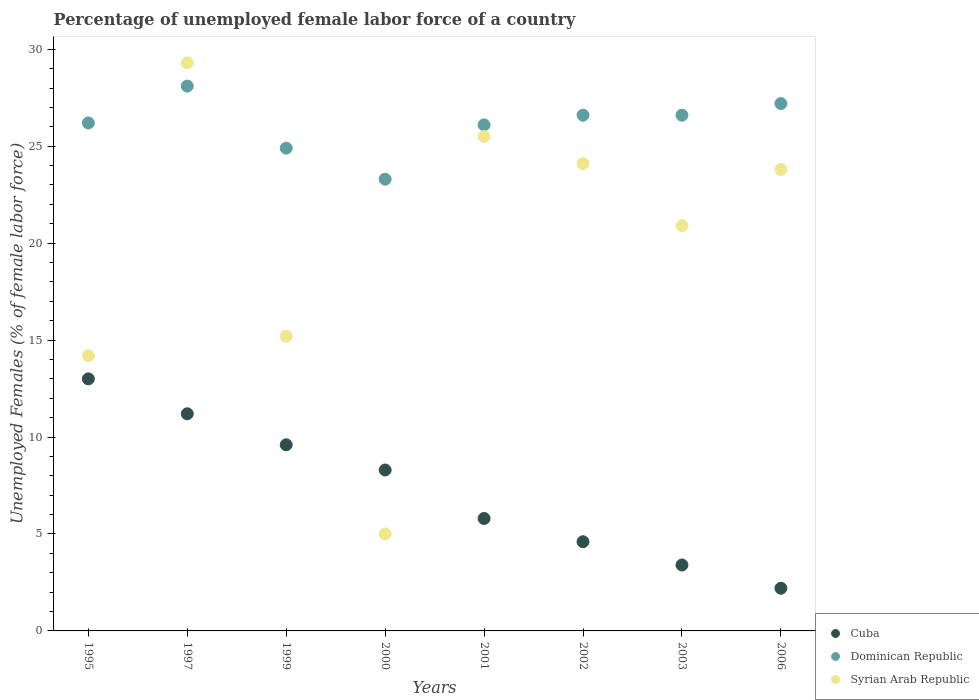Is the number of dotlines equal to the number of legend labels?
Make the answer very short. Yes. Across all years, what is the maximum percentage of unemployed female labor force in Dominican Republic?
Provide a short and direct response. 28.1. Across all years, what is the minimum percentage of unemployed female labor force in Dominican Republic?
Offer a terse response. 23.3. What is the total percentage of unemployed female labor force in Cuba in the graph?
Provide a short and direct response. 58.1. What is the difference between the percentage of unemployed female labor force in Syrian Arab Republic in 2002 and that in 2006?
Offer a very short reply. 0.3. What is the difference between the percentage of unemployed female labor force in Syrian Arab Republic in 2003 and the percentage of unemployed female labor force in Cuba in 2000?
Your response must be concise. 12.6. What is the average percentage of unemployed female labor force in Cuba per year?
Give a very brief answer. 7.26. In the year 2002, what is the difference between the percentage of unemployed female labor force in Cuba and percentage of unemployed female labor force in Dominican Republic?
Give a very brief answer. -22. What is the ratio of the percentage of unemployed female labor force in Syrian Arab Republic in 2000 to that in 2006?
Your response must be concise. 0.21. What is the difference between the highest and the second highest percentage of unemployed female labor force in Cuba?
Ensure brevity in your answer.  1.8. What is the difference between the highest and the lowest percentage of unemployed female labor force in Dominican Republic?
Ensure brevity in your answer.  4.8. Is the sum of the percentage of unemployed female labor force in Dominican Republic in 1997 and 2002 greater than the maximum percentage of unemployed female labor force in Syrian Arab Republic across all years?
Give a very brief answer. Yes. Is it the case that in every year, the sum of the percentage of unemployed female labor force in Dominican Republic and percentage of unemployed female labor force in Cuba  is greater than the percentage of unemployed female labor force in Syrian Arab Republic?
Your answer should be very brief. Yes. Does the percentage of unemployed female labor force in Cuba monotonically increase over the years?
Offer a very short reply. No. Is the percentage of unemployed female labor force in Syrian Arab Republic strictly greater than the percentage of unemployed female labor force in Cuba over the years?
Offer a very short reply. No. How many years are there in the graph?
Provide a short and direct response. 8. Are the values on the major ticks of Y-axis written in scientific E-notation?
Give a very brief answer. No. Does the graph contain any zero values?
Ensure brevity in your answer.  No. How many legend labels are there?
Offer a very short reply. 3. How are the legend labels stacked?
Your answer should be compact. Vertical. What is the title of the graph?
Provide a short and direct response. Percentage of unemployed female labor force of a country. Does "Georgia" appear as one of the legend labels in the graph?
Your answer should be compact. No. What is the label or title of the Y-axis?
Provide a short and direct response. Unemployed Females (% of female labor force). What is the Unemployed Females (% of female labor force) in Cuba in 1995?
Your answer should be very brief. 13. What is the Unemployed Females (% of female labor force) of Dominican Republic in 1995?
Give a very brief answer. 26.2. What is the Unemployed Females (% of female labor force) in Syrian Arab Republic in 1995?
Give a very brief answer. 14.2. What is the Unemployed Females (% of female labor force) in Cuba in 1997?
Your answer should be very brief. 11.2. What is the Unemployed Females (% of female labor force) in Dominican Republic in 1997?
Your response must be concise. 28.1. What is the Unemployed Females (% of female labor force) of Syrian Arab Republic in 1997?
Ensure brevity in your answer.  29.3. What is the Unemployed Females (% of female labor force) in Cuba in 1999?
Offer a very short reply. 9.6. What is the Unemployed Females (% of female labor force) in Dominican Republic in 1999?
Make the answer very short. 24.9. What is the Unemployed Females (% of female labor force) of Syrian Arab Republic in 1999?
Offer a very short reply. 15.2. What is the Unemployed Females (% of female labor force) of Cuba in 2000?
Provide a short and direct response. 8.3. What is the Unemployed Females (% of female labor force) in Dominican Republic in 2000?
Provide a succinct answer. 23.3. What is the Unemployed Females (% of female labor force) of Cuba in 2001?
Provide a short and direct response. 5.8. What is the Unemployed Females (% of female labor force) in Dominican Republic in 2001?
Keep it short and to the point. 26.1. What is the Unemployed Females (% of female labor force) in Syrian Arab Republic in 2001?
Give a very brief answer. 25.5. What is the Unemployed Females (% of female labor force) in Cuba in 2002?
Your answer should be very brief. 4.6. What is the Unemployed Females (% of female labor force) of Dominican Republic in 2002?
Your response must be concise. 26.6. What is the Unemployed Females (% of female labor force) in Syrian Arab Republic in 2002?
Offer a terse response. 24.1. What is the Unemployed Females (% of female labor force) of Cuba in 2003?
Make the answer very short. 3.4. What is the Unemployed Females (% of female labor force) in Dominican Republic in 2003?
Provide a short and direct response. 26.6. What is the Unemployed Females (% of female labor force) of Syrian Arab Republic in 2003?
Ensure brevity in your answer.  20.9. What is the Unemployed Females (% of female labor force) of Cuba in 2006?
Your answer should be very brief. 2.2. What is the Unemployed Females (% of female labor force) of Dominican Republic in 2006?
Make the answer very short. 27.2. What is the Unemployed Females (% of female labor force) of Syrian Arab Republic in 2006?
Provide a short and direct response. 23.8. Across all years, what is the maximum Unemployed Females (% of female labor force) of Dominican Republic?
Your response must be concise. 28.1. Across all years, what is the maximum Unemployed Females (% of female labor force) in Syrian Arab Republic?
Ensure brevity in your answer.  29.3. Across all years, what is the minimum Unemployed Females (% of female labor force) of Cuba?
Your answer should be very brief. 2.2. Across all years, what is the minimum Unemployed Females (% of female labor force) of Dominican Republic?
Offer a very short reply. 23.3. Across all years, what is the minimum Unemployed Females (% of female labor force) of Syrian Arab Republic?
Your response must be concise. 5. What is the total Unemployed Females (% of female labor force) of Cuba in the graph?
Your response must be concise. 58.1. What is the total Unemployed Females (% of female labor force) in Dominican Republic in the graph?
Your response must be concise. 209. What is the total Unemployed Females (% of female labor force) in Syrian Arab Republic in the graph?
Keep it short and to the point. 158. What is the difference between the Unemployed Females (% of female labor force) of Cuba in 1995 and that in 1997?
Make the answer very short. 1.8. What is the difference between the Unemployed Females (% of female labor force) of Dominican Republic in 1995 and that in 1997?
Offer a terse response. -1.9. What is the difference between the Unemployed Females (% of female labor force) in Syrian Arab Republic in 1995 and that in 1997?
Provide a short and direct response. -15.1. What is the difference between the Unemployed Females (% of female labor force) in Cuba in 1995 and that in 1999?
Your response must be concise. 3.4. What is the difference between the Unemployed Females (% of female labor force) of Cuba in 1995 and that in 2000?
Your response must be concise. 4.7. What is the difference between the Unemployed Females (% of female labor force) of Dominican Republic in 1995 and that in 2000?
Provide a short and direct response. 2.9. What is the difference between the Unemployed Females (% of female labor force) of Syrian Arab Republic in 1995 and that in 2000?
Your answer should be compact. 9.2. What is the difference between the Unemployed Females (% of female labor force) of Cuba in 1995 and that in 2001?
Ensure brevity in your answer.  7.2. What is the difference between the Unemployed Females (% of female labor force) in Dominican Republic in 1995 and that in 2001?
Provide a short and direct response. 0.1. What is the difference between the Unemployed Females (% of female labor force) of Syrian Arab Republic in 1995 and that in 2001?
Offer a terse response. -11.3. What is the difference between the Unemployed Females (% of female labor force) in Cuba in 1995 and that in 2002?
Provide a succinct answer. 8.4. What is the difference between the Unemployed Females (% of female labor force) of Dominican Republic in 1995 and that in 2002?
Give a very brief answer. -0.4. What is the difference between the Unemployed Females (% of female labor force) in Cuba in 1997 and that in 1999?
Offer a very short reply. 1.6. What is the difference between the Unemployed Females (% of female labor force) in Dominican Republic in 1997 and that in 1999?
Your response must be concise. 3.2. What is the difference between the Unemployed Females (% of female labor force) in Cuba in 1997 and that in 2000?
Offer a very short reply. 2.9. What is the difference between the Unemployed Females (% of female labor force) of Syrian Arab Republic in 1997 and that in 2000?
Provide a short and direct response. 24.3. What is the difference between the Unemployed Females (% of female labor force) in Cuba in 1997 and that in 2001?
Offer a very short reply. 5.4. What is the difference between the Unemployed Females (% of female labor force) in Syrian Arab Republic in 1997 and that in 2001?
Provide a short and direct response. 3.8. What is the difference between the Unemployed Females (% of female labor force) of Dominican Republic in 1997 and that in 2002?
Your answer should be compact. 1.5. What is the difference between the Unemployed Females (% of female labor force) in Dominican Republic in 1997 and that in 2003?
Provide a succinct answer. 1.5. What is the difference between the Unemployed Females (% of female labor force) of Syrian Arab Republic in 1997 and that in 2003?
Give a very brief answer. 8.4. What is the difference between the Unemployed Females (% of female labor force) of Syrian Arab Republic in 1997 and that in 2006?
Provide a succinct answer. 5.5. What is the difference between the Unemployed Females (% of female labor force) of Syrian Arab Republic in 1999 and that in 2000?
Offer a very short reply. 10.2. What is the difference between the Unemployed Females (% of female labor force) in Dominican Republic in 1999 and that in 2001?
Your answer should be compact. -1.2. What is the difference between the Unemployed Females (% of female labor force) in Dominican Republic in 1999 and that in 2002?
Make the answer very short. -1.7. What is the difference between the Unemployed Females (% of female labor force) in Dominican Republic in 1999 and that in 2003?
Your response must be concise. -1.7. What is the difference between the Unemployed Females (% of female labor force) of Cuba in 1999 and that in 2006?
Your answer should be compact. 7.4. What is the difference between the Unemployed Females (% of female labor force) of Syrian Arab Republic in 1999 and that in 2006?
Ensure brevity in your answer.  -8.6. What is the difference between the Unemployed Females (% of female labor force) in Dominican Republic in 2000 and that in 2001?
Provide a short and direct response. -2.8. What is the difference between the Unemployed Females (% of female labor force) of Syrian Arab Republic in 2000 and that in 2001?
Offer a very short reply. -20.5. What is the difference between the Unemployed Females (% of female labor force) in Dominican Republic in 2000 and that in 2002?
Provide a short and direct response. -3.3. What is the difference between the Unemployed Females (% of female labor force) of Syrian Arab Republic in 2000 and that in 2002?
Offer a terse response. -19.1. What is the difference between the Unemployed Females (% of female labor force) of Dominican Republic in 2000 and that in 2003?
Your response must be concise. -3.3. What is the difference between the Unemployed Females (% of female labor force) of Syrian Arab Republic in 2000 and that in 2003?
Provide a short and direct response. -15.9. What is the difference between the Unemployed Females (% of female labor force) in Syrian Arab Republic in 2000 and that in 2006?
Provide a short and direct response. -18.8. What is the difference between the Unemployed Females (% of female labor force) in Cuba in 2001 and that in 2002?
Offer a very short reply. 1.2. What is the difference between the Unemployed Females (% of female labor force) in Syrian Arab Republic in 2001 and that in 2002?
Your response must be concise. 1.4. What is the difference between the Unemployed Females (% of female labor force) in Dominican Republic in 2001 and that in 2003?
Your answer should be very brief. -0.5. What is the difference between the Unemployed Females (% of female labor force) of Cuba in 2001 and that in 2006?
Offer a very short reply. 3.6. What is the difference between the Unemployed Females (% of female labor force) of Syrian Arab Republic in 2001 and that in 2006?
Make the answer very short. 1.7. What is the difference between the Unemployed Females (% of female labor force) of Syrian Arab Republic in 2002 and that in 2003?
Keep it short and to the point. 3.2. What is the difference between the Unemployed Females (% of female labor force) in Dominican Republic in 2002 and that in 2006?
Your answer should be very brief. -0.6. What is the difference between the Unemployed Females (% of female labor force) of Cuba in 2003 and that in 2006?
Provide a succinct answer. 1.2. What is the difference between the Unemployed Females (% of female labor force) in Dominican Republic in 2003 and that in 2006?
Provide a short and direct response. -0.6. What is the difference between the Unemployed Females (% of female labor force) of Syrian Arab Republic in 2003 and that in 2006?
Offer a very short reply. -2.9. What is the difference between the Unemployed Females (% of female labor force) in Cuba in 1995 and the Unemployed Females (% of female labor force) in Dominican Republic in 1997?
Your answer should be very brief. -15.1. What is the difference between the Unemployed Females (% of female labor force) in Cuba in 1995 and the Unemployed Females (% of female labor force) in Syrian Arab Republic in 1997?
Give a very brief answer. -16.3. What is the difference between the Unemployed Females (% of female labor force) in Dominican Republic in 1995 and the Unemployed Females (% of female labor force) in Syrian Arab Republic in 1997?
Your answer should be very brief. -3.1. What is the difference between the Unemployed Females (% of female labor force) in Dominican Republic in 1995 and the Unemployed Females (% of female labor force) in Syrian Arab Republic in 1999?
Keep it short and to the point. 11. What is the difference between the Unemployed Females (% of female labor force) in Cuba in 1995 and the Unemployed Females (% of female labor force) in Dominican Republic in 2000?
Your answer should be compact. -10.3. What is the difference between the Unemployed Females (% of female labor force) of Dominican Republic in 1995 and the Unemployed Females (% of female labor force) of Syrian Arab Republic in 2000?
Your answer should be compact. 21.2. What is the difference between the Unemployed Females (% of female labor force) in Dominican Republic in 1995 and the Unemployed Females (% of female labor force) in Syrian Arab Republic in 2001?
Ensure brevity in your answer.  0.7. What is the difference between the Unemployed Females (% of female labor force) in Cuba in 1995 and the Unemployed Females (% of female labor force) in Dominican Republic in 2002?
Your answer should be very brief. -13.6. What is the difference between the Unemployed Females (% of female labor force) of Cuba in 1995 and the Unemployed Females (% of female labor force) of Syrian Arab Republic in 2003?
Ensure brevity in your answer.  -7.9. What is the difference between the Unemployed Females (% of female labor force) in Dominican Republic in 1995 and the Unemployed Females (% of female labor force) in Syrian Arab Republic in 2003?
Provide a short and direct response. 5.3. What is the difference between the Unemployed Females (% of female labor force) of Cuba in 1995 and the Unemployed Females (% of female labor force) of Syrian Arab Republic in 2006?
Keep it short and to the point. -10.8. What is the difference between the Unemployed Females (% of female labor force) of Cuba in 1997 and the Unemployed Females (% of female labor force) of Dominican Republic in 1999?
Provide a succinct answer. -13.7. What is the difference between the Unemployed Females (% of female labor force) of Cuba in 1997 and the Unemployed Females (% of female labor force) of Syrian Arab Republic in 1999?
Your response must be concise. -4. What is the difference between the Unemployed Females (% of female labor force) in Cuba in 1997 and the Unemployed Females (% of female labor force) in Dominican Republic in 2000?
Your response must be concise. -12.1. What is the difference between the Unemployed Females (% of female labor force) of Cuba in 1997 and the Unemployed Females (% of female labor force) of Syrian Arab Republic in 2000?
Keep it short and to the point. 6.2. What is the difference between the Unemployed Females (% of female labor force) of Dominican Republic in 1997 and the Unemployed Females (% of female labor force) of Syrian Arab Republic in 2000?
Your answer should be compact. 23.1. What is the difference between the Unemployed Females (% of female labor force) of Cuba in 1997 and the Unemployed Females (% of female labor force) of Dominican Republic in 2001?
Give a very brief answer. -14.9. What is the difference between the Unemployed Females (% of female labor force) in Cuba in 1997 and the Unemployed Females (% of female labor force) in Syrian Arab Republic in 2001?
Keep it short and to the point. -14.3. What is the difference between the Unemployed Females (% of female labor force) in Dominican Republic in 1997 and the Unemployed Females (% of female labor force) in Syrian Arab Republic in 2001?
Offer a terse response. 2.6. What is the difference between the Unemployed Females (% of female labor force) in Cuba in 1997 and the Unemployed Females (% of female labor force) in Dominican Republic in 2002?
Provide a succinct answer. -15.4. What is the difference between the Unemployed Females (% of female labor force) of Cuba in 1997 and the Unemployed Females (% of female labor force) of Syrian Arab Republic in 2002?
Give a very brief answer. -12.9. What is the difference between the Unemployed Females (% of female labor force) in Dominican Republic in 1997 and the Unemployed Females (% of female labor force) in Syrian Arab Republic in 2002?
Give a very brief answer. 4. What is the difference between the Unemployed Females (% of female labor force) in Cuba in 1997 and the Unemployed Females (% of female labor force) in Dominican Republic in 2003?
Offer a terse response. -15.4. What is the difference between the Unemployed Females (% of female labor force) in Cuba in 1999 and the Unemployed Females (% of female labor force) in Dominican Republic in 2000?
Keep it short and to the point. -13.7. What is the difference between the Unemployed Females (% of female labor force) of Cuba in 1999 and the Unemployed Females (% of female labor force) of Syrian Arab Republic in 2000?
Offer a very short reply. 4.6. What is the difference between the Unemployed Females (% of female labor force) in Dominican Republic in 1999 and the Unemployed Females (% of female labor force) in Syrian Arab Republic in 2000?
Your response must be concise. 19.9. What is the difference between the Unemployed Females (% of female labor force) of Cuba in 1999 and the Unemployed Females (% of female labor force) of Dominican Republic in 2001?
Provide a succinct answer. -16.5. What is the difference between the Unemployed Females (% of female labor force) of Cuba in 1999 and the Unemployed Females (% of female labor force) of Syrian Arab Republic in 2001?
Your answer should be compact. -15.9. What is the difference between the Unemployed Females (% of female labor force) of Dominican Republic in 1999 and the Unemployed Females (% of female labor force) of Syrian Arab Republic in 2002?
Your answer should be very brief. 0.8. What is the difference between the Unemployed Females (% of female labor force) of Cuba in 1999 and the Unemployed Females (% of female labor force) of Dominican Republic in 2003?
Make the answer very short. -17. What is the difference between the Unemployed Females (% of female labor force) of Cuba in 1999 and the Unemployed Females (% of female labor force) of Dominican Republic in 2006?
Your response must be concise. -17.6. What is the difference between the Unemployed Females (% of female labor force) of Cuba in 1999 and the Unemployed Females (% of female labor force) of Syrian Arab Republic in 2006?
Offer a terse response. -14.2. What is the difference between the Unemployed Females (% of female labor force) in Cuba in 2000 and the Unemployed Females (% of female labor force) in Dominican Republic in 2001?
Provide a succinct answer. -17.8. What is the difference between the Unemployed Females (% of female labor force) in Cuba in 2000 and the Unemployed Females (% of female labor force) in Syrian Arab Republic in 2001?
Offer a terse response. -17.2. What is the difference between the Unemployed Females (% of female labor force) in Dominican Republic in 2000 and the Unemployed Females (% of female labor force) in Syrian Arab Republic in 2001?
Provide a succinct answer. -2.2. What is the difference between the Unemployed Females (% of female labor force) in Cuba in 2000 and the Unemployed Females (% of female labor force) in Dominican Republic in 2002?
Your answer should be compact. -18.3. What is the difference between the Unemployed Females (% of female labor force) of Cuba in 2000 and the Unemployed Females (% of female labor force) of Syrian Arab Republic in 2002?
Offer a very short reply. -15.8. What is the difference between the Unemployed Females (% of female labor force) of Cuba in 2000 and the Unemployed Females (% of female labor force) of Dominican Republic in 2003?
Ensure brevity in your answer.  -18.3. What is the difference between the Unemployed Females (% of female labor force) in Cuba in 2000 and the Unemployed Females (% of female labor force) in Syrian Arab Republic in 2003?
Offer a terse response. -12.6. What is the difference between the Unemployed Females (% of female labor force) of Cuba in 2000 and the Unemployed Females (% of female labor force) of Dominican Republic in 2006?
Your answer should be very brief. -18.9. What is the difference between the Unemployed Females (% of female labor force) in Cuba in 2000 and the Unemployed Females (% of female labor force) in Syrian Arab Republic in 2006?
Ensure brevity in your answer.  -15.5. What is the difference between the Unemployed Females (% of female labor force) in Cuba in 2001 and the Unemployed Females (% of female labor force) in Dominican Republic in 2002?
Your answer should be compact. -20.8. What is the difference between the Unemployed Females (% of female labor force) in Cuba in 2001 and the Unemployed Females (% of female labor force) in Syrian Arab Republic in 2002?
Your answer should be compact. -18.3. What is the difference between the Unemployed Females (% of female labor force) of Cuba in 2001 and the Unemployed Females (% of female labor force) of Dominican Republic in 2003?
Make the answer very short. -20.8. What is the difference between the Unemployed Females (% of female labor force) in Cuba in 2001 and the Unemployed Females (% of female labor force) in Syrian Arab Republic in 2003?
Ensure brevity in your answer.  -15.1. What is the difference between the Unemployed Females (% of female labor force) of Cuba in 2001 and the Unemployed Females (% of female labor force) of Dominican Republic in 2006?
Your answer should be compact. -21.4. What is the difference between the Unemployed Females (% of female labor force) in Dominican Republic in 2001 and the Unemployed Females (% of female labor force) in Syrian Arab Republic in 2006?
Make the answer very short. 2.3. What is the difference between the Unemployed Females (% of female labor force) of Cuba in 2002 and the Unemployed Females (% of female labor force) of Syrian Arab Republic in 2003?
Offer a terse response. -16.3. What is the difference between the Unemployed Females (% of female labor force) in Cuba in 2002 and the Unemployed Females (% of female labor force) in Dominican Republic in 2006?
Provide a short and direct response. -22.6. What is the difference between the Unemployed Females (% of female labor force) in Cuba in 2002 and the Unemployed Females (% of female labor force) in Syrian Arab Republic in 2006?
Keep it short and to the point. -19.2. What is the difference between the Unemployed Females (% of female labor force) in Cuba in 2003 and the Unemployed Females (% of female labor force) in Dominican Republic in 2006?
Provide a succinct answer. -23.8. What is the difference between the Unemployed Females (% of female labor force) of Cuba in 2003 and the Unemployed Females (% of female labor force) of Syrian Arab Republic in 2006?
Your response must be concise. -20.4. What is the difference between the Unemployed Females (% of female labor force) in Dominican Republic in 2003 and the Unemployed Females (% of female labor force) in Syrian Arab Republic in 2006?
Keep it short and to the point. 2.8. What is the average Unemployed Females (% of female labor force) in Cuba per year?
Ensure brevity in your answer.  7.26. What is the average Unemployed Females (% of female labor force) of Dominican Republic per year?
Your response must be concise. 26.12. What is the average Unemployed Females (% of female labor force) of Syrian Arab Republic per year?
Your response must be concise. 19.75. In the year 1995, what is the difference between the Unemployed Females (% of female labor force) in Cuba and Unemployed Females (% of female labor force) in Syrian Arab Republic?
Your answer should be compact. -1.2. In the year 1995, what is the difference between the Unemployed Females (% of female labor force) of Dominican Republic and Unemployed Females (% of female labor force) of Syrian Arab Republic?
Provide a succinct answer. 12. In the year 1997, what is the difference between the Unemployed Females (% of female labor force) in Cuba and Unemployed Females (% of female labor force) in Dominican Republic?
Make the answer very short. -16.9. In the year 1997, what is the difference between the Unemployed Females (% of female labor force) in Cuba and Unemployed Females (% of female labor force) in Syrian Arab Republic?
Provide a succinct answer. -18.1. In the year 1999, what is the difference between the Unemployed Females (% of female labor force) in Cuba and Unemployed Females (% of female labor force) in Dominican Republic?
Give a very brief answer. -15.3. In the year 1999, what is the difference between the Unemployed Females (% of female labor force) in Cuba and Unemployed Females (% of female labor force) in Syrian Arab Republic?
Provide a short and direct response. -5.6. In the year 1999, what is the difference between the Unemployed Females (% of female labor force) of Dominican Republic and Unemployed Females (% of female labor force) of Syrian Arab Republic?
Provide a succinct answer. 9.7. In the year 2001, what is the difference between the Unemployed Females (% of female labor force) in Cuba and Unemployed Females (% of female labor force) in Dominican Republic?
Offer a very short reply. -20.3. In the year 2001, what is the difference between the Unemployed Females (% of female labor force) of Cuba and Unemployed Females (% of female labor force) of Syrian Arab Republic?
Ensure brevity in your answer.  -19.7. In the year 2002, what is the difference between the Unemployed Females (% of female labor force) in Cuba and Unemployed Females (% of female labor force) in Syrian Arab Republic?
Keep it short and to the point. -19.5. In the year 2003, what is the difference between the Unemployed Females (% of female labor force) of Cuba and Unemployed Females (% of female labor force) of Dominican Republic?
Your response must be concise. -23.2. In the year 2003, what is the difference between the Unemployed Females (% of female labor force) of Cuba and Unemployed Females (% of female labor force) of Syrian Arab Republic?
Provide a short and direct response. -17.5. In the year 2003, what is the difference between the Unemployed Females (% of female labor force) in Dominican Republic and Unemployed Females (% of female labor force) in Syrian Arab Republic?
Provide a succinct answer. 5.7. In the year 2006, what is the difference between the Unemployed Females (% of female labor force) in Cuba and Unemployed Females (% of female labor force) in Dominican Republic?
Keep it short and to the point. -25. In the year 2006, what is the difference between the Unemployed Females (% of female labor force) in Cuba and Unemployed Females (% of female labor force) in Syrian Arab Republic?
Give a very brief answer. -21.6. In the year 2006, what is the difference between the Unemployed Females (% of female labor force) in Dominican Republic and Unemployed Females (% of female labor force) in Syrian Arab Republic?
Give a very brief answer. 3.4. What is the ratio of the Unemployed Females (% of female labor force) of Cuba in 1995 to that in 1997?
Your answer should be very brief. 1.16. What is the ratio of the Unemployed Females (% of female labor force) in Dominican Republic in 1995 to that in 1997?
Give a very brief answer. 0.93. What is the ratio of the Unemployed Females (% of female labor force) of Syrian Arab Republic in 1995 to that in 1997?
Give a very brief answer. 0.48. What is the ratio of the Unemployed Females (% of female labor force) in Cuba in 1995 to that in 1999?
Ensure brevity in your answer.  1.35. What is the ratio of the Unemployed Females (% of female labor force) of Dominican Republic in 1995 to that in 1999?
Make the answer very short. 1.05. What is the ratio of the Unemployed Females (% of female labor force) in Syrian Arab Republic in 1995 to that in 1999?
Your answer should be very brief. 0.93. What is the ratio of the Unemployed Females (% of female labor force) in Cuba in 1995 to that in 2000?
Your response must be concise. 1.57. What is the ratio of the Unemployed Females (% of female labor force) of Dominican Republic in 1995 to that in 2000?
Your answer should be very brief. 1.12. What is the ratio of the Unemployed Females (% of female labor force) of Syrian Arab Republic in 1995 to that in 2000?
Provide a short and direct response. 2.84. What is the ratio of the Unemployed Females (% of female labor force) of Cuba in 1995 to that in 2001?
Ensure brevity in your answer.  2.24. What is the ratio of the Unemployed Females (% of female labor force) in Dominican Republic in 1995 to that in 2001?
Provide a short and direct response. 1. What is the ratio of the Unemployed Females (% of female labor force) of Syrian Arab Republic in 1995 to that in 2001?
Keep it short and to the point. 0.56. What is the ratio of the Unemployed Females (% of female labor force) of Cuba in 1995 to that in 2002?
Give a very brief answer. 2.83. What is the ratio of the Unemployed Females (% of female labor force) of Syrian Arab Republic in 1995 to that in 2002?
Provide a short and direct response. 0.59. What is the ratio of the Unemployed Females (% of female labor force) of Cuba in 1995 to that in 2003?
Make the answer very short. 3.82. What is the ratio of the Unemployed Females (% of female labor force) in Syrian Arab Republic in 1995 to that in 2003?
Your response must be concise. 0.68. What is the ratio of the Unemployed Females (% of female labor force) of Cuba in 1995 to that in 2006?
Your answer should be compact. 5.91. What is the ratio of the Unemployed Females (% of female labor force) in Dominican Republic in 1995 to that in 2006?
Offer a very short reply. 0.96. What is the ratio of the Unemployed Females (% of female labor force) of Syrian Arab Republic in 1995 to that in 2006?
Provide a short and direct response. 0.6. What is the ratio of the Unemployed Females (% of female labor force) in Cuba in 1997 to that in 1999?
Ensure brevity in your answer.  1.17. What is the ratio of the Unemployed Females (% of female labor force) in Dominican Republic in 1997 to that in 1999?
Your response must be concise. 1.13. What is the ratio of the Unemployed Females (% of female labor force) in Syrian Arab Republic in 1997 to that in 1999?
Ensure brevity in your answer.  1.93. What is the ratio of the Unemployed Females (% of female labor force) of Cuba in 1997 to that in 2000?
Provide a succinct answer. 1.35. What is the ratio of the Unemployed Females (% of female labor force) of Dominican Republic in 1997 to that in 2000?
Give a very brief answer. 1.21. What is the ratio of the Unemployed Females (% of female labor force) in Syrian Arab Republic in 1997 to that in 2000?
Keep it short and to the point. 5.86. What is the ratio of the Unemployed Females (% of female labor force) of Cuba in 1997 to that in 2001?
Keep it short and to the point. 1.93. What is the ratio of the Unemployed Females (% of female labor force) of Dominican Republic in 1997 to that in 2001?
Make the answer very short. 1.08. What is the ratio of the Unemployed Females (% of female labor force) in Syrian Arab Republic in 1997 to that in 2001?
Make the answer very short. 1.15. What is the ratio of the Unemployed Females (% of female labor force) of Cuba in 1997 to that in 2002?
Your response must be concise. 2.43. What is the ratio of the Unemployed Females (% of female labor force) in Dominican Republic in 1997 to that in 2002?
Make the answer very short. 1.06. What is the ratio of the Unemployed Females (% of female labor force) in Syrian Arab Republic in 1997 to that in 2002?
Your response must be concise. 1.22. What is the ratio of the Unemployed Females (% of female labor force) of Cuba in 1997 to that in 2003?
Provide a succinct answer. 3.29. What is the ratio of the Unemployed Females (% of female labor force) in Dominican Republic in 1997 to that in 2003?
Keep it short and to the point. 1.06. What is the ratio of the Unemployed Females (% of female labor force) of Syrian Arab Republic in 1997 to that in 2003?
Keep it short and to the point. 1.4. What is the ratio of the Unemployed Females (% of female labor force) in Cuba in 1997 to that in 2006?
Your response must be concise. 5.09. What is the ratio of the Unemployed Females (% of female labor force) of Dominican Republic in 1997 to that in 2006?
Your response must be concise. 1.03. What is the ratio of the Unemployed Females (% of female labor force) in Syrian Arab Republic in 1997 to that in 2006?
Provide a short and direct response. 1.23. What is the ratio of the Unemployed Females (% of female labor force) of Cuba in 1999 to that in 2000?
Ensure brevity in your answer.  1.16. What is the ratio of the Unemployed Females (% of female labor force) of Dominican Republic in 1999 to that in 2000?
Offer a very short reply. 1.07. What is the ratio of the Unemployed Females (% of female labor force) of Syrian Arab Republic in 1999 to that in 2000?
Your answer should be very brief. 3.04. What is the ratio of the Unemployed Females (% of female labor force) in Cuba in 1999 to that in 2001?
Make the answer very short. 1.66. What is the ratio of the Unemployed Females (% of female labor force) of Dominican Republic in 1999 to that in 2001?
Keep it short and to the point. 0.95. What is the ratio of the Unemployed Females (% of female labor force) of Syrian Arab Republic in 1999 to that in 2001?
Ensure brevity in your answer.  0.6. What is the ratio of the Unemployed Females (% of female labor force) of Cuba in 1999 to that in 2002?
Offer a terse response. 2.09. What is the ratio of the Unemployed Females (% of female labor force) in Dominican Republic in 1999 to that in 2002?
Provide a succinct answer. 0.94. What is the ratio of the Unemployed Females (% of female labor force) of Syrian Arab Republic in 1999 to that in 2002?
Provide a short and direct response. 0.63. What is the ratio of the Unemployed Females (% of female labor force) of Cuba in 1999 to that in 2003?
Ensure brevity in your answer.  2.82. What is the ratio of the Unemployed Females (% of female labor force) in Dominican Republic in 1999 to that in 2003?
Your answer should be compact. 0.94. What is the ratio of the Unemployed Females (% of female labor force) in Syrian Arab Republic in 1999 to that in 2003?
Offer a terse response. 0.73. What is the ratio of the Unemployed Females (% of female labor force) of Cuba in 1999 to that in 2006?
Offer a very short reply. 4.36. What is the ratio of the Unemployed Females (% of female labor force) of Dominican Republic in 1999 to that in 2006?
Offer a very short reply. 0.92. What is the ratio of the Unemployed Females (% of female labor force) of Syrian Arab Republic in 1999 to that in 2006?
Give a very brief answer. 0.64. What is the ratio of the Unemployed Females (% of female labor force) in Cuba in 2000 to that in 2001?
Keep it short and to the point. 1.43. What is the ratio of the Unemployed Females (% of female labor force) in Dominican Republic in 2000 to that in 2001?
Your answer should be compact. 0.89. What is the ratio of the Unemployed Females (% of female labor force) in Syrian Arab Republic in 2000 to that in 2001?
Ensure brevity in your answer.  0.2. What is the ratio of the Unemployed Females (% of female labor force) in Cuba in 2000 to that in 2002?
Keep it short and to the point. 1.8. What is the ratio of the Unemployed Females (% of female labor force) of Dominican Republic in 2000 to that in 2002?
Your answer should be very brief. 0.88. What is the ratio of the Unemployed Females (% of female labor force) in Syrian Arab Republic in 2000 to that in 2002?
Your answer should be compact. 0.21. What is the ratio of the Unemployed Females (% of female labor force) of Cuba in 2000 to that in 2003?
Your answer should be compact. 2.44. What is the ratio of the Unemployed Females (% of female labor force) in Dominican Republic in 2000 to that in 2003?
Your answer should be very brief. 0.88. What is the ratio of the Unemployed Females (% of female labor force) of Syrian Arab Republic in 2000 to that in 2003?
Offer a terse response. 0.24. What is the ratio of the Unemployed Females (% of female labor force) of Cuba in 2000 to that in 2006?
Give a very brief answer. 3.77. What is the ratio of the Unemployed Females (% of female labor force) of Dominican Republic in 2000 to that in 2006?
Offer a very short reply. 0.86. What is the ratio of the Unemployed Females (% of female labor force) of Syrian Arab Republic in 2000 to that in 2006?
Your answer should be very brief. 0.21. What is the ratio of the Unemployed Females (% of female labor force) in Cuba in 2001 to that in 2002?
Make the answer very short. 1.26. What is the ratio of the Unemployed Females (% of female labor force) in Dominican Republic in 2001 to that in 2002?
Ensure brevity in your answer.  0.98. What is the ratio of the Unemployed Females (% of female labor force) of Syrian Arab Republic in 2001 to that in 2002?
Offer a terse response. 1.06. What is the ratio of the Unemployed Females (% of female labor force) in Cuba in 2001 to that in 2003?
Provide a succinct answer. 1.71. What is the ratio of the Unemployed Females (% of female labor force) of Dominican Republic in 2001 to that in 2003?
Make the answer very short. 0.98. What is the ratio of the Unemployed Females (% of female labor force) in Syrian Arab Republic in 2001 to that in 2003?
Keep it short and to the point. 1.22. What is the ratio of the Unemployed Females (% of female labor force) of Cuba in 2001 to that in 2006?
Your answer should be very brief. 2.64. What is the ratio of the Unemployed Females (% of female labor force) of Dominican Republic in 2001 to that in 2006?
Keep it short and to the point. 0.96. What is the ratio of the Unemployed Females (% of female labor force) of Syrian Arab Republic in 2001 to that in 2006?
Provide a succinct answer. 1.07. What is the ratio of the Unemployed Females (% of female labor force) in Cuba in 2002 to that in 2003?
Give a very brief answer. 1.35. What is the ratio of the Unemployed Females (% of female labor force) in Syrian Arab Republic in 2002 to that in 2003?
Give a very brief answer. 1.15. What is the ratio of the Unemployed Females (% of female labor force) of Cuba in 2002 to that in 2006?
Your response must be concise. 2.09. What is the ratio of the Unemployed Females (% of female labor force) in Dominican Republic in 2002 to that in 2006?
Offer a terse response. 0.98. What is the ratio of the Unemployed Females (% of female labor force) in Syrian Arab Republic in 2002 to that in 2006?
Your answer should be compact. 1.01. What is the ratio of the Unemployed Females (% of female labor force) in Cuba in 2003 to that in 2006?
Your answer should be very brief. 1.55. What is the ratio of the Unemployed Females (% of female labor force) in Dominican Republic in 2003 to that in 2006?
Offer a very short reply. 0.98. What is the ratio of the Unemployed Females (% of female labor force) in Syrian Arab Republic in 2003 to that in 2006?
Ensure brevity in your answer.  0.88. What is the difference between the highest and the second highest Unemployed Females (% of female labor force) in Cuba?
Make the answer very short. 1.8. What is the difference between the highest and the second highest Unemployed Females (% of female labor force) of Dominican Republic?
Offer a terse response. 0.9. What is the difference between the highest and the second highest Unemployed Females (% of female labor force) in Syrian Arab Republic?
Offer a very short reply. 3.8. What is the difference between the highest and the lowest Unemployed Females (% of female labor force) in Cuba?
Offer a very short reply. 10.8. What is the difference between the highest and the lowest Unemployed Females (% of female labor force) in Syrian Arab Republic?
Your answer should be very brief. 24.3. 